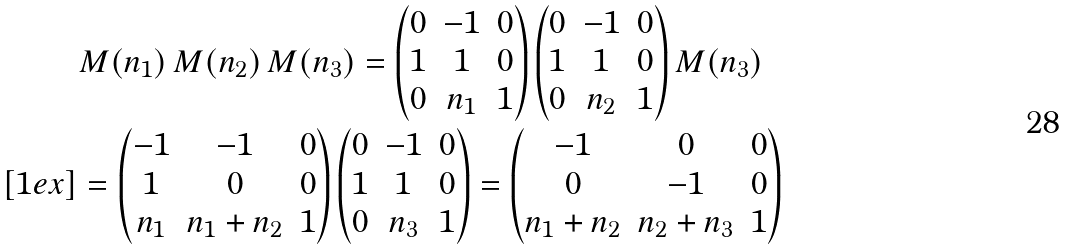<formula> <loc_0><loc_0><loc_500><loc_500>& M ( n _ { 1 } ) \, M ( n _ { 2 } ) \, M ( n _ { 3 } ) = \begin{pmatrix} 0 & - 1 & 0 \\ 1 & 1 & 0 \\ 0 & n _ { 1 } & 1 \end{pmatrix} \begin{pmatrix} 0 & - 1 & 0 \\ 1 & 1 & 0 \\ 0 & n _ { 2 } & 1 \end{pmatrix} M ( n _ { 3 } ) \\ [ 1 e x ] & = \begin{pmatrix} - 1 & - 1 & 0 \\ 1 & 0 & 0 \\ n _ { 1 } & n _ { 1 } + n _ { 2 } & 1 \end{pmatrix} \begin{pmatrix} 0 & - 1 & 0 \\ 1 & 1 & 0 \\ 0 & n _ { 3 } & 1 \end{pmatrix} = \begin{pmatrix} - 1 & 0 & 0 \\ 0 & - 1 & 0 \\ n _ { 1 } + n _ { 2 } & n _ { 2 } + n _ { 3 } & 1 \end{pmatrix}</formula> 